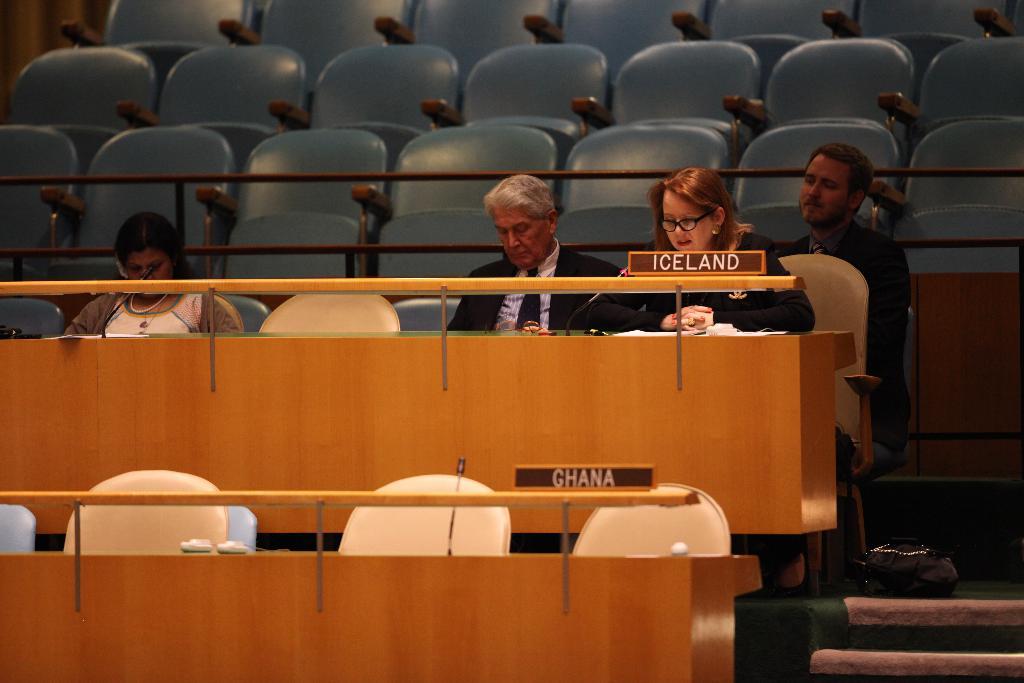What country has people sitting by its desk?
Provide a short and direct response. Iceland. 